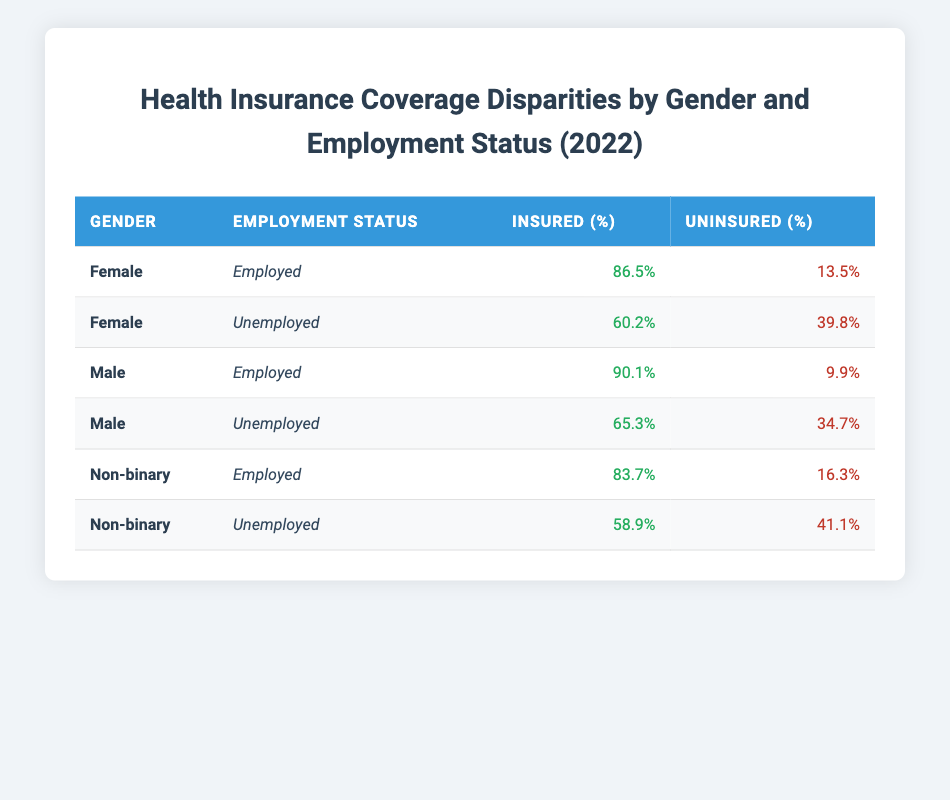What is the insurance coverage percentage for employed females? The table shows that the insurance coverage percentage for employed females is 86.5%.
Answer: 86.5% What percentage of unemployed males are uninsured? From the table, the uninsured percentage for unemployed males is 34.7%.
Answer: 34.7% Which gender has the highest insurance coverage among employed individuals? The table indicates that employed males have the highest insurance coverage at 90.1%.
Answer: Males What is the difference in insurance coverage percentage between unemployed females and unemployed non-binary individuals? Unemployed females have an insurance coverage percentage of 60.2% while unemployed non-binary individuals have 58.9%. The difference is 60.2% - 58.9% = 1.3%.
Answer: 1.3% Is the insurance coverage for employed non-binary individuals greater than that for unemployed males? The insurance coverage percentage for employed non-binary individuals is 83.7%, while for unemployed males, it is 65.3%. Therefore, the statement is true.
Answer: Yes What is the average insurance coverage percentage for all unemployed individuals across genders? The uninsured percentages for unemployed females, males, and non-binary individuals are 39.8%, 34.7%, and 41.1%, respectively. This corresponds to insurance coverage percentages of 60.2%, 65.3%, and 58.9%. Summing these percentages gives 60.2% + 65.3% + 58.9% = 184.4%. Dividing by 3 (the number of groups) results in an average of 184.4%/3 = 61.47%.
Answer: 61.47% Do employed females have a higher insured percentage than non-binary individuals who are unemployed? Employed females have an insurance coverage percentage of 86.5%, whereas unemployed non-binary individuals have an insurance coverage percentage of 58.9%. Therefore, the statement is true.
Answer: Yes What is the percentage of uninsured employed non-binary individuals? The uninsured percentage for employed non-binary individuals is 16.3%.
Answer: 16.3% What can we conclude about the disparity in health insurance coverage between unemployed females and employed males? The table shows that unemployed females have a lower insurance coverage percentage of 60.2% compared to employed males who have an insurance coverage percentage of 90.1%. The disparity is significant.
Answer: Significant disparity 